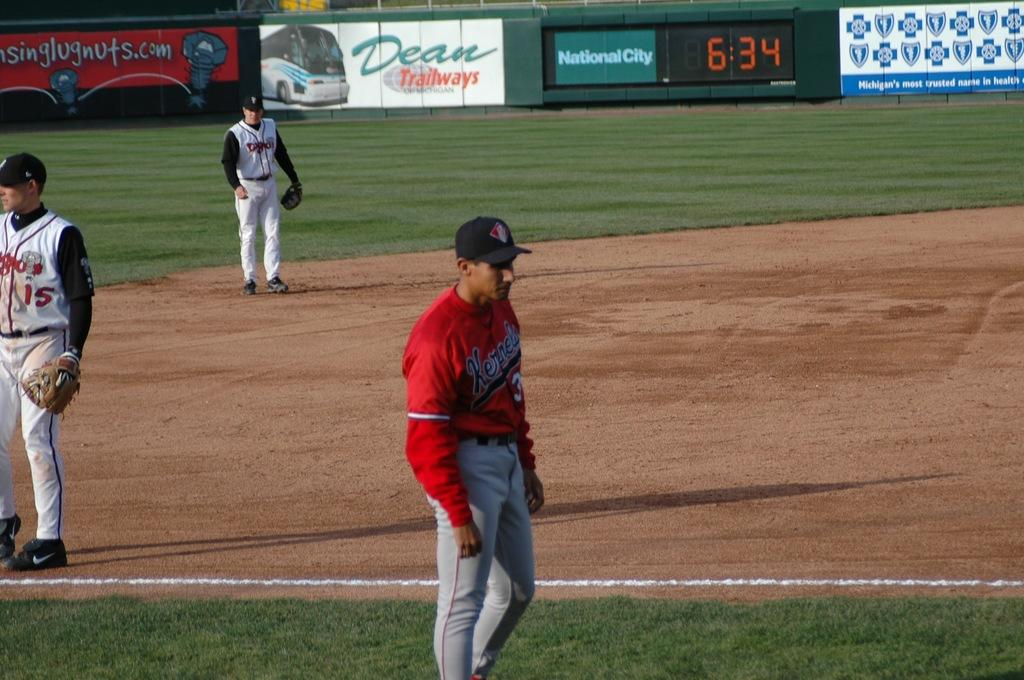<image>
Give a short and clear explanation of the subsequent image. Baseball players stand around the field waiting for the timer to resume at 6:34. 